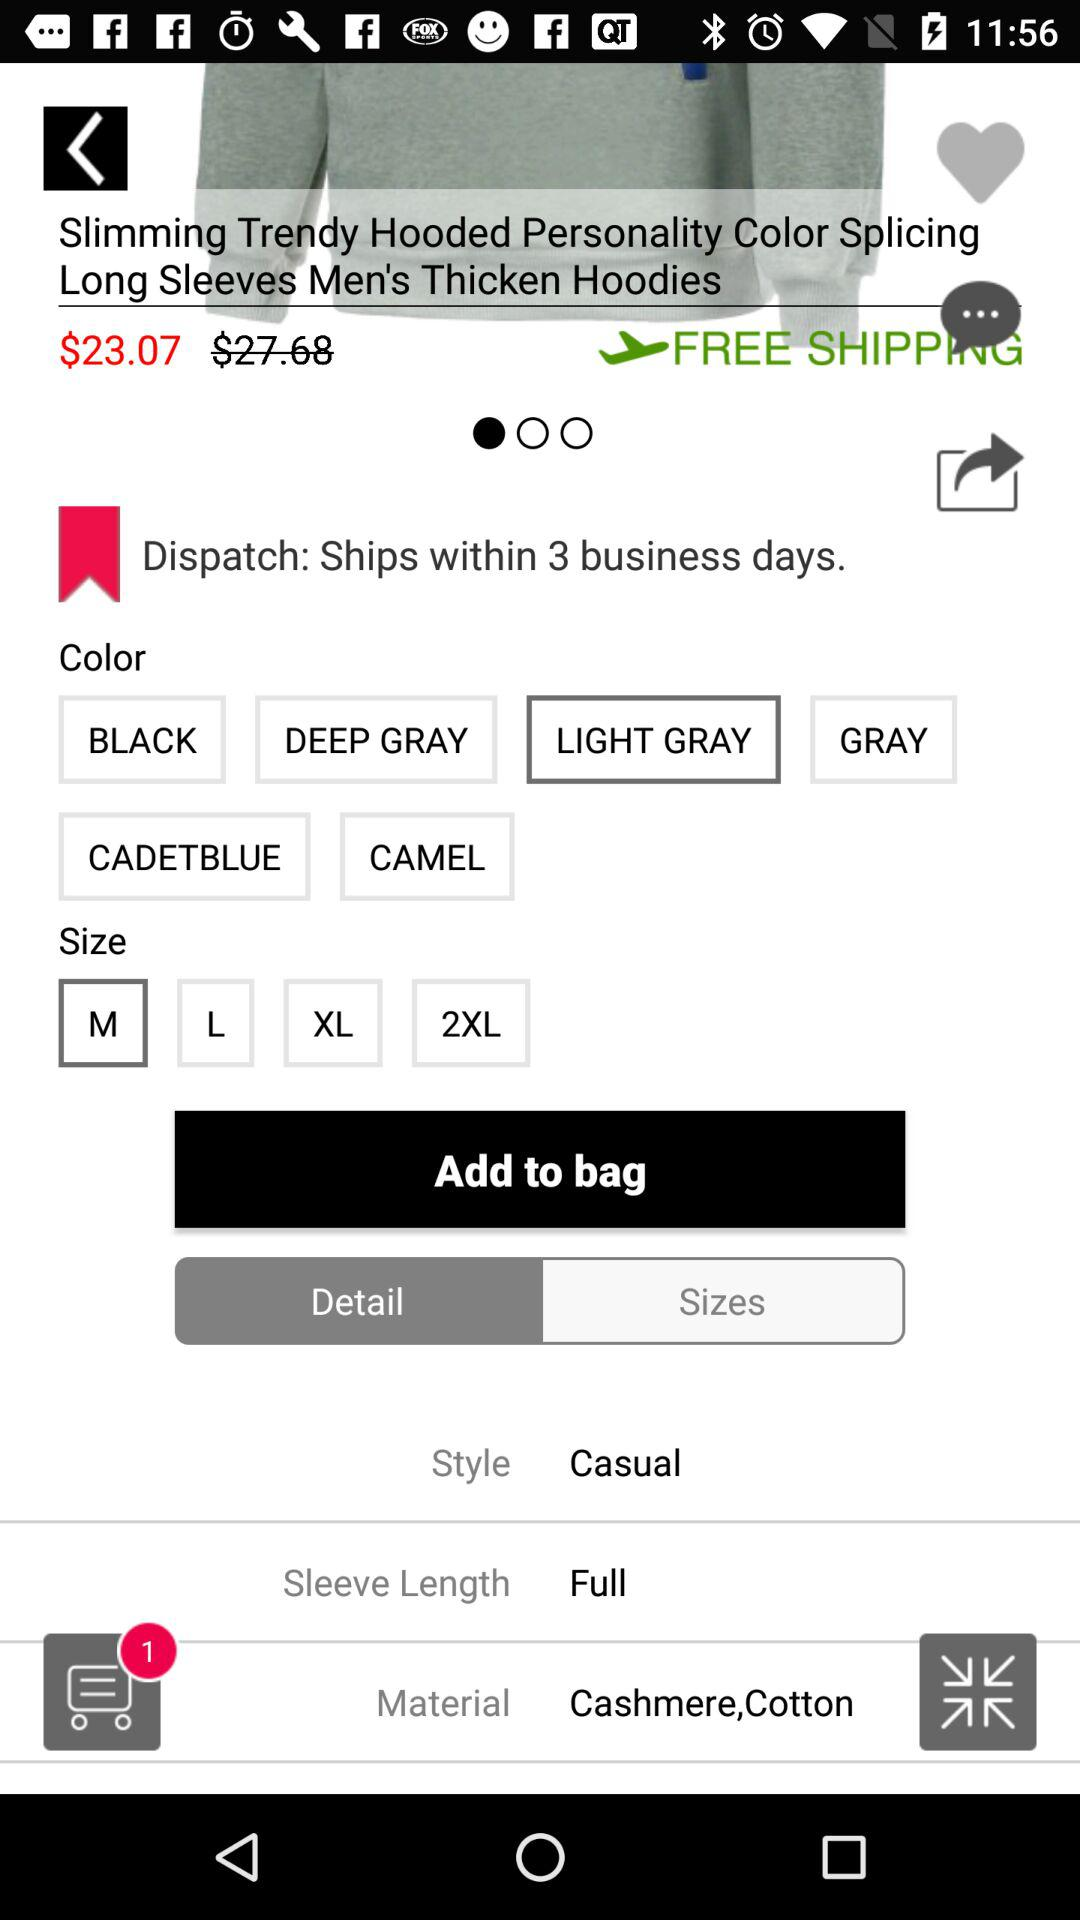What are the shipping charges?
Answer the question using a single word or phrase. Shipping is free. 